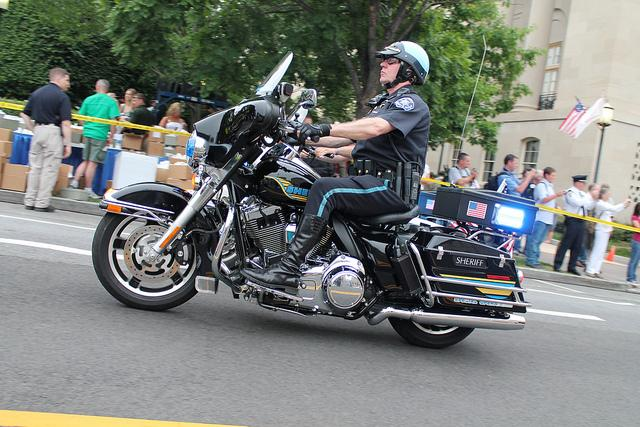What is the name of the nation with the flag in this picture? Please explain your reasoning. united states. The red blue and white colors with stars and stripes identifies the flag's in this image as american ones. 